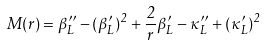Convert formula to latex. <formula><loc_0><loc_0><loc_500><loc_500>M ( r ) = \beta _ { L } ^ { \prime \prime } - ( \beta _ { L } ^ { \prime } ) ^ { 2 } + \frac { 2 } { r } \beta _ { L } ^ { \prime } - \kappa _ { L } ^ { \prime \prime } + ( \kappa _ { L } ^ { \prime } ) ^ { 2 }</formula> 